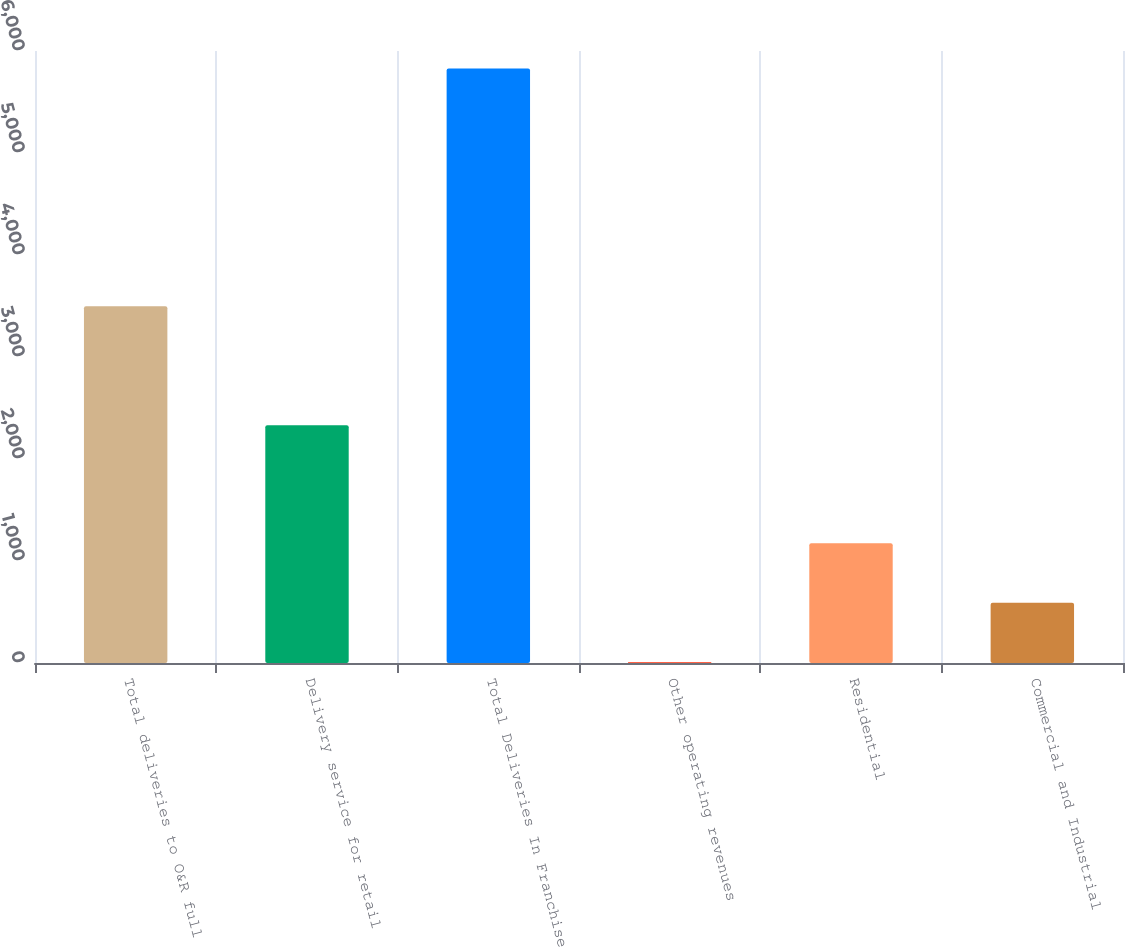Convert chart. <chart><loc_0><loc_0><loc_500><loc_500><bar_chart><fcel>Total deliveries to O&R full<fcel>Delivery service for retail<fcel>Total Deliveries In Franchise<fcel>Other operating revenues<fcel>Residential<fcel>Commercial and Industrial<nl><fcel>3498<fcel>2330<fcel>5828<fcel>10<fcel>1173.6<fcel>591.8<nl></chart> 